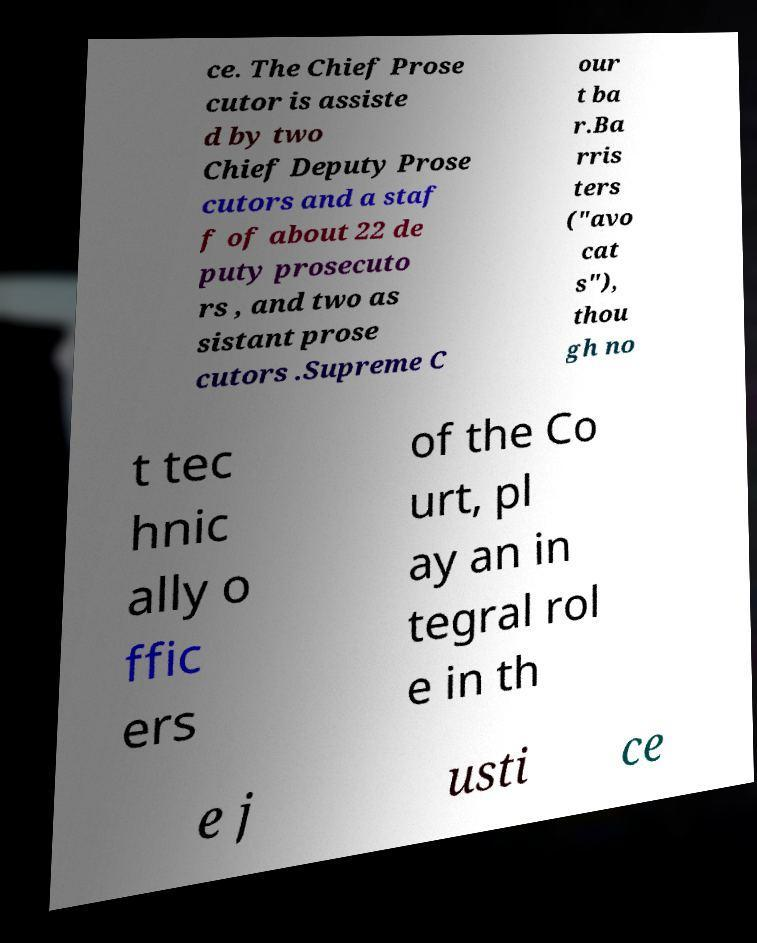Could you assist in decoding the text presented in this image and type it out clearly? ce. The Chief Prose cutor is assiste d by two Chief Deputy Prose cutors and a staf f of about 22 de puty prosecuto rs , and two as sistant prose cutors .Supreme C our t ba r.Ba rris ters ("avo cat s"), thou gh no t tec hnic ally o ffic ers of the Co urt, pl ay an in tegral rol e in th e j usti ce 